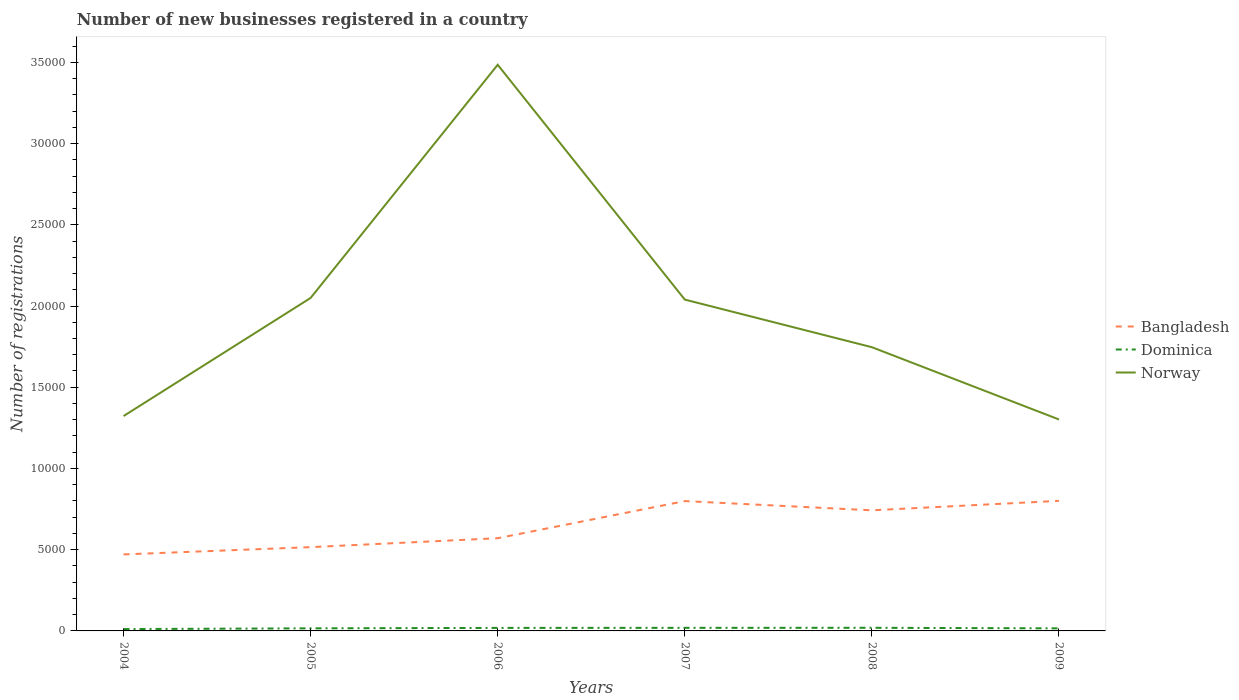How many different coloured lines are there?
Offer a terse response. 3. Across all years, what is the maximum number of new businesses registered in Dominica?
Offer a very short reply. 114. What is the total number of new businesses registered in Norway in the graph?
Keep it short and to the point. 7379. What is the difference between the highest and the second highest number of new businesses registered in Dominica?
Keep it short and to the point. 79. How many years are there in the graph?
Provide a succinct answer. 6. What is the difference between two consecutive major ticks on the Y-axis?
Provide a short and direct response. 5000. Are the values on the major ticks of Y-axis written in scientific E-notation?
Your answer should be compact. No. Does the graph contain any zero values?
Provide a succinct answer. No. Does the graph contain grids?
Keep it short and to the point. No. How many legend labels are there?
Offer a terse response. 3. How are the legend labels stacked?
Give a very brief answer. Vertical. What is the title of the graph?
Provide a short and direct response. Number of new businesses registered in a country. Does "Uganda" appear as one of the legend labels in the graph?
Provide a short and direct response. No. What is the label or title of the Y-axis?
Offer a very short reply. Number of registrations. What is the Number of registrations in Bangladesh in 2004?
Your answer should be compact. 4710. What is the Number of registrations of Dominica in 2004?
Your answer should be very brief. 114. What is the Number of registrations of Norway in 2004?
Your answer should be very brief. 1.32e+04. What is the Number of registrations of Bangladesh in 2005?
Make the answer very short. 5157. What is the Number of registrations in Dominica in 2005?
Offer a very short reply. 159. What is the Number of registrations of Norway in 2005?
Give a very brief answer. 2.05e+04. What is the Number of registrations in Bangladesh in 2006?
Your answer should be very brief. 5707. What is the Number of registrations in Dominica in 2006?
Offer a terse response. 186. What is the Number of registrations in Norway in 2006?
Give a very brief answer. 3.48e+04. What is the Number of registrations in Bangladesh in 2007?
Offer a terse response. 7992. What is the Number of registrations in Dominica in 2007?
Provide a short and direct response. 190. What is the Number of registrations in Norway in 2007?
Offer a very short reply. 2.04e+04. What is the Number of registrations of Bangladesh in 2008?
Your answer should be very brief. 7425. What is the Number of registrations of Dominica in 2008?
Provide a succinct answer. 193. What is the Number of registrations of Norway in 2008?
Ensure brevity in your answer.  1.75e+04. What is the Number of registrations of Bangladesh in 2009?
Offer a very short reply. 8007. What is the Number of registrations in Dominica in 2009?
Keep it short and to the point. 158. What is the Number of registrations in Norway in 2009?
Offer a very short reply. 1.30e+04. Across all years, what is the maximum Number of registrations in Bangladesh?
Your response must be concise. 8007. Across all years, what is the maximum Number of registrations in Dominica?
Provide a short and direct response. 193. Across all years, what is the maximum Number of registrations of Norway?
Provide a succinct answer. 3.48e+04. Across all years, what is the minimum Number of registrations of Bangladesh?
Keep it short and to the point. 4710. Across all years, what is the minimum Number of registrations of Dominica?
Provide a succinct answer. 114. Across all years, what is the minimum Number of registrations of Norway?
Provide a succinct answer. 1.30e+04. What is the total Number of registrations in Bangladesh in the graph?
Your answer should be very brief. 3.90e+04. What is the total Number of registrations in Norway in the graph?
Ensure brevity in your answer.  1.19e+05. What is the difference between the Number of registrations in Bangladesh in 2004 and that in 2005?
Your response must be concise. -447. What is the difference between the Number of registrations in Dominica in 2004 and that in 2005?
Make the answer very short. -45. What is the difference between the Number of registrations in Norway in 2004 and that in 2005?
Make the answer very short. -7272. What is the difference between the Number of registrations of Bangladesh in 2004 and that in 2006?
Provide a short and direct response. -997. What is the difference between the Number of registrations of Dominica in 2004 and that in 2006?
Provide a succinct answer. -72. What is the difference between the Number of registrations in Norway in 2004 and that in 2006?
Your answer should be very brief. -2.16e+04. What is the difference between the Number of registrations in Bangladesh in 2004 and that in 2007?
Give a very brief answer. -3282. What is the difference between the Number of registrations in Dominica in 2004 and that in 2007?
Offer a very short reply. -76. What is the difference between the Number of registrations of Norway in 2004 and that in 2007?
Ensure brevity in your answer.  -7170. What is the difference between the Number of registrations in Bangladesh in 2004 and that in 2008?
Your answer should be very brief. -2715. What is the difference between the Number of registrations in Dominica in 2004 and that in 2008?
Give a very brief answer. -79. What is the difference between the Number of registrations in Norway in 2004 and that in 2008?
Make the answer very short. -4240. What is the difference between the Number of registrations of Bangladesh in 2004 and that in 2009?
Give a very brief answer. -3297. What is the difference between the Number of registrations in Dominica in 2004 and that in 2009?
Provide a short and direct response. -44. What is the difference between the Number of registrations in Norway in 2004 and that in 2009?
Keep it short and to the point. 209. What is the difference between the Number of registrations in Bangladesh in 2005 and that in 2006?
Offer a very short reply. -550. What is the difference between the Number of registrations in Dominica in 2005 and that in 2006?
Give a very brief answer. -27. What is the difference between the Number of registrations of Norway in 2005 and that in 2006?
Keep it short and to the point. -1.44e+04. What is the difference between the Number of registrations in Bangladesh in 2005 and that in 2007?
Keep it short and to the point. -2835. What is the difference between the Number of registrations in Dominica in 2005 and that in 2007?
Give a very brief answer. -31. What is the difference between the Number of registrations of Norway in 2005 and that in 2007?
Provide a short and direct response. 102. What is the difference between the Number of registrations in Bangladesh in 2005 and that in 2008?
Your answer should be compact. -2268. What is the difference between the Number of registrations of Dominica in 2005 and that in 2008?
Your answer should be very brief. -34. What is the difference between the Number of registrations in Norway in 2005 and that in 2008?
Your answer should be compact. 3032. What is the difference between the Number of registrations in Bangladesh in 2005 and that in 2009?
Give a very brief answer. -2850. What is the difference between the Number of registrations of Dominica in 2005 and that in 2009?
Offer a terse response. 1. What is the difference between the Number of registrations in Norway in 2005 and that in 2009?
Give a very brief answer. 7481. What is the difference between the Number of registrations in Bangladesh in 2006 and that in 2007?
Your response must be concise. -2285. What is the difference between the Number of registrations of Dominica in 2006 and that in 2007?
Your answer should be very brief. -4. What is the difference between the Number of registrations in Norway in 2006 and that in 2007?
Offer a terse response. 1.45e+04. What is the difference between the Number of registrations of Bangladesh in 2006 and that in 2008?
Provide a short and direct response. -1718. What is the difference between the Number of registrations of Dominica in 2006 and that in 2008?
Your answer should be compact. -7. What is the difference between the Number of registrations of Norway in 2006 and that in 2008?
Make the answer very short. 1.74e+04. What is the difference between the Number of registrations of Bangladesh in 2006 and that in 2009?
Keep it short and to the point. -2300. What is the difference between the Number of registrations in Dominica in 2006 and that in 2009?
Offer a terse response. 28. What is the difference between the Number of registrations of Norway in 2006 and that in 2009?
Give a very brief answer. 2.18e+04. What is the difference between the Number of registrations of Bangladesh in 2007 and that in 2008?
Your response must be concise. 567. What is the difference between the Number of registrations of Dominica in 2007 and that in 2008?
Ensure brevity in your answer.  -3. What is the difference between the Number of registrations in Norway in 2007 and that in 2008?
Your answer should be compact. 2930. What is the difference between the Number of registrations in Bangladesh in 2007 and that in 2009?
Make the answer very short. -15. What is the difference between the Number of registrations of Dominica in 2007 and that in 2009?
Make the answer very short. 32. What is the difference between the Number of registrations of Norway in 2007 and that in 2009?
Keep it short and to the point. 7379. What is the difference between the Number of registrations of Bangladesh in 2008 and that in 2009?
Offer a terse response. -582. What is the difference between the Number of registrations in Dominica in 2008 and that in 2009?
Your response must be concise. 35. What is the difference between the Number of registrations of Norway in 2008 and that in 2009?
Provide a short and direct response. 4449. What is the difference between the Number of registrations in Bangladesh in 2004 and the Number of registrations in Dominica in 2005?
Make the answer very short. 4551. What is the difference between the Number of registrations in Bangladesh in 2004 and the Number of registrations in Norway in 2005?
Provide a short and direct response. -1.58e+04. What is the difference between the Number of registrations in Dominica in 2004 and the Number of registrations in Norway in 2005?
Offer a very short reply. -2.04e+04. What is the difference between the Number of registrations in Bangladesh in 2004 and the Number of registrations in Dominica in 2006?
Give a very brief answer. 4524. What is the difference between the Number of registrations in Bangladesh in 2004 and the Number of registrations in Norway in 2006?
Provide a short and direct response. -3.01e+04. What is the difference between the Number of registrations in Dominica in 2004 and the Number of registrations in Norway in 2006?
Your answer should be compact. -3.47e+04. What is the difference between the Number of registrations in Bangladesh in 2004 and the Number of registrations in Dominica in 2007?
Your answer should be compact. 4520. What is the difference between the Number of registrations in Bangladesh in 2004 and the Number of registrations in Norway in 2007?
Your response must be concise. -1.57e+04. What is the difference between the Number of registrations in Dominica in 2004 and the Number of registrations in Norway in 2007?
Provide a succinct answer. -2.03e+04. What is the difference between the Number of registrations of Bangladesh in 2004 and the Number of registrations of Dominica in 2008?
Keep it short and to the point. 4517. What is the difference between the Number of registrations in Bangladesh in 2004 and the Number of registrations in Norway in 2008?
Make the answer very short. -1.28e+04. What is the difference between the Number of registrations of Dominica in 2004 and the Number of registrations of Norway in 2008?
Your response must be concise. -1.74e+04. What is the difference between the Number of registrations in Bangladesh in 2004 and the Number of registrations in Dominica in 2009?
Ensure brevity in your answer.  4552. What is the difference between the Number of registrations in Bangladesh in 2004 and the Number of registrations in Norway in 2009?
Make the answer very short. -8306. What is the difference between the Number of registrations in Dominica in 2004 and the Number of registrations in Norway in 2009?
Offer a terse response. -1.29e+04. What is the difference between the Number of registrations in Bangladesh in 2005 and the Number of registrations in Dominica in 2006?
Your answer should be very brief. 4971. What is the difference between the Number of registrations in Bangladesh in 2005 and the Number of registrations in Norway in 2006?
Offer a terse response. -2.97e+04. What is the difference between the Number of registrations of Dominica in 2005 and the Number of registrations of Norway in 2006?
Provide a succinct answer. -3.47e+04. What is the difference between the Number of registrations of Bangladesh in 2005 and the Number of registrations of Dominica in 2007?
Offer a terse response. 4967. What is the difference between the Number of registrations of Bangladesh in 2005 and the Number of registrations of Norway in 2007?
Your response must be concise. -1.52e+04. What is the difference between the Number of registrations of Dominica in 2005 and the Number of registrations of Norway in 2007?
Your answer should be compact. -2.02e+04. What is the difference between the Number of registrations in Bangladesh in 2005 and the Number of registrations in Dominica in 2008?
Give a very brief answer. 4964. What is the difference between the Number of registrations in Bangladesh in 2005 and the Number of registrations in Norway in 2008?
Your answer should be very brief. -1.23e+04. What is the difference between the Number of registrations of Dominica in 2005 and the Number of registrations of Norway in 2008?
Ensure brevity in your answer.  -1.73e+04. What is the difference between the Number of registrations of Bangladesh in 2005 and the Number of registrations of Dominica in 2009?
Your answer should be compact. 4999. What is the difference between the Number of registrations of Bangladesh in 2005 and the Number of registrations of Norway in 2009?
Ensure brevity in your answer.  -7859. What is the difference between the Number of registrations in Dominica in 2005 and the Number of registrations in Norway in 2009?
Offer a terse response. -1.29e+04. What is the difference between the Number of registrations of Bangladesh in 2006 and the Number of registrations of Dominica in 2007?
Keep it short and to the point. 5517. What is the difference between the Number of registrations in Bangladesh in 2006 and the Number of registrations in Norway in 2007?
Your response must be concise. -1.47e+04. What is the difference between the Number of registrations in Dominica in 2006 and the Number of registrations in Norway in 2007?
Offer a very short reply. -2.02e+04. What is the difference between the Number of registrations in Bangladesh in 2006 and the Number of registrations in Dominica in 2008?
Offer a very short reply. 5514. What is the difference between the Number of registrations in Bangladesh in 2006 and the Number of registrations in Norway in 2008?
Make the answer very short. -1.18e+04. What is the difference between the Number of registrations in Dominica in 2006 and the Number of registrations in Norway in 2008?
Provide a succinct answer. -1.73e+04. What is the difference between the Number of registrations in Bangladesh in 2006 and the Number of registrations in Dominica in 2009?
Your answer should be compact. 5549. What is the difference between the Number of registrations of Bangladesh in 2006 and the Number of registrations of Norway in 2009?
Provide a succinct answer. -7309. What is the difference between the Number of registrations of Dominica in 2006 and the Number of registrations of Norway in 2009?
Keep it short and to the point. -1.28e+04. What is the difference between the Number of registrations in Bangladesh in 2007 and the Number of registrations in Dominica in 2008?
Provide a succinct answer. 7799. What is the difference between the Number of registrations of Bangladesh in 2007 and the Number of registrations of Norway in 2008?
Provide a short and direct response. -9473. What is the difference between the Number of registrations in Dominica in 2007 and the Number of registrations in Norway in 2008?
Give a very brief answer. -1.73e+04. What is the difference between the Number of registrations of Bangladesh in 2007 and the Number of registrations of Dominica in 2009?
Offer a very short reply. 7834. What is the difference between the Number of registrations of Bangladesh in 2007 and the Number of registrations of Norway in 2009?
Ensure brevity in your answer.  -5024. What is the difference between the Number of registrations in Dominica in 2007 and the Number of registrations in Norway in 2009?
Offer a terse response. -1.28e+04. What is the difference between the Number of registrations in Bangladesh in 2008 and the Number of registrations in Dominica in 2009?
Your answer should be very brief. 7267. What is the difference between the Number of registrations of Bangladesh in 2008 and the Number of registrations of Norway in 2009?
Give a very brief answer. -5591. What is the difference between the Number of registrations of Dominica in 2008 and the Number of registrations of Norway in 2009?
Offer a very short reply. -1.28e+04. What is the average Number of registrations in Bangladesh per year?
Your answer should be compact. 6499.67. What is the average Number of registrations of Dominica per year?
Offer a very short reply. 166.67. What is the average Number of registrations of Norway per year?
Your response must be concise. 1.99e+04. In the year 2004, what is the difference between the Number of registrations in Bangladesh and Number of registrations in Dominica?
Your response must be concise. 4596. In the year 2004, what is the difference between the Number of registrations of Bangladesh and Number of registrations of Norway?
Provide a short and direct response. -8515. In the year 2004, what is the difference between the Number of registrations of Dominica and Number of registrations of Norway?
Give a very brief answer. -1.31e+04. In the year 2005, what is the difference between the Number of registrations of Bangladesh and Number of registrations of Dominica?
Keep it short and to the point. 4998. In the year 2005, what is the difference between the Number of registrations in Bangladesh and Number of registrations in Norway?
Provide a succinct answer. -1.53e+04. In the year 2005, what is the difference between the Number of registrations in Dominica and Number of registrations in Norway?
Your answer should be very brief. -2.03e+04. In the year 2006, what is the difference between the Number of registrations in Bangladesh and Number of registrations in Dominica?
Your answer should be very brief. 5521. In the year 2006, what is the difference between the Number of registrations in Bangladesh and Number of registrations in Norway?
Offer a very short reply. -2.91e+04. In the year 2006, what is the difference between the Number of registrations in Dominica and Number of registrations in Norway?
Offer a terse response. -3.47e+04. In the year 2007, what is the difference between the Number of registrations in Bangladesh and Number of registrations in Dominica?
Your answer should be compact. 7802. In the year 2007, what is the difference between the Number of registrations in Bangladesh and Number of registrations in Norway?
Give a very brief answer. -1.24e+04. In the year 2007, what is the difference between the Number of registrations of Dominica and Number of registrations of Norway?
Ensure brevity in your answer.  -2.02e+04. In the year 2008, what is the difference between the Number of registrations in Bangladesh and Number of registrations in Dominica?
Offer a very short reply. 7232. In the year 2008, what is the difference between the Number of registrations in Bangladesh and Number of registrations in Norway?
Provide a short and direct response. -1.00e+04. In the year 2008, what is the difference between the Number of registrations of Dominica and Number of registrations of Norway?
Make the answer very short. -1.73e+04. In the year 2009, what is the difference between the Number of registrations of Bangladesh and Number of registrations of Dominica?
Provide a succinct answer. 7849. In the year 2009, what is the difference between the Number of registrations of Bangladesh and Number of registrations of Norway?
Offer a very short reply. -5009. In the year 2009, what is the difference between the Number of registrations of Dominica and Number of registrations of Norway?
Your response must be concise. -1.29e+04. What is the ratio of the Number of registrations of Bangladesh in 2004 to that in 2005?
Make the answer very short. 0.91. What is the ratio of the Number of registrations in Dominica in 2004 to that in 2005?
Ensure brevity in your answer.  0.72. What is the ratio of the Number of registrations of Norway in 2004 to that in 2005?
Provide a short and direct response. 0.65. What is the ratio of the Number of registrations of Bangladesh in 2004 to that in 2006?
Provide a short and direct response. 0.83. What is the ratio of the Number of registrations in Dominica in 2004 to that in 2006?
Provide a succinct answer. 0.61. What is the ratio of the Number of registrations of Norway in 2004 to that in 2006?
Offer a terse response. 0.38. What is the ratio of the Number of registrations in Bangladesh in 2004 to that in 2007?
Offer a terse response. 0.59. What is the ratio of the Number of registrations of Dominica in 2004 to that in 2007?
Keep it short and to the point. 0.6. What is the ratio of the Number of registrations in Norway in 2004 to that in 2007?
Ensure brevity in your answer.  0.65. What is the ratio of the Number of registrations of Bangladesh in 2004 to that in 2008?
Give a very brief answer. 0.63. What is the ratio of the Number of registrations in Dominica in 2004 to that in 2008?
Make the answer very short. 0.59. What is the ratio of the Number of registrations in Norway in 2004 to that in 2008?
Keep it short and to the point. 0.76. What is the ratio of the Number of registrations in Bangladesh in 2004 to that in 2009?
Your answer should be compact. 0.59. What is the ratio of the Number of registrations of Dominica in 2004 to that in 2009?
Ensure brevity in your answer.  0.72. What is the ratio of the Number of registrations in Norway in 2004 to that in 2009?
Ensure brevity in your answer.  1.02. What is the ratio of the Number of registrations of Bangladesh in 2005 to that in 2006?
Make the answer very short. 0.9. What is the ratio of the Number of registrations in Dominica in 2005 to that in 2006?
Ensure brevity in your answer.  0.85. What is the ratio of the Number of registrations of Norway in 2005 to that in 2006?
Offer a terse response. 0.59. What is the ratio of the Number of registrations in Bangladesh in 2005 to that in 2007?
Offer a terse response. 0.65. What is the ratio of the Number of registrations of Dominica in 2005 to that in 2007?
Offer a terse response. 0.84. What is the ratio of the Number of registrations of Bangladesh in 2005 to that in 2008?
Provide a succinct answer. 0.69. What is the ratio of the Number of registrations of Dominica in 2005 to that in 2008?
Make the answer very short. 0.82. What is the ratio of the Number of registrations in Norway in 2005 to that in 2008?
Provide a short and direct response. 1.17. What is the ratio of the Number of registrations in Bangladesh in 2005 to that in 2009?
Make the answer very short. 0.64. What is the ratio of the Number of registrations in Dominica in 2005 to that in 2009?
Keep it short and to the point. 1.01. What is the ratio of the Number of registrations in Norway in 2005 to that in 2009?
Offer a very short reply. 1.57. What is the ratio of the Number of registrations of Bangladesh in 2006 to that in 2007?
Give a very brief answer. 0.71. What is the ratio of the Number of registrations in Dominica in 2006 to that in 2007?
Give a very brief answer. 0.98. What is the ratio of the Number of registrations of Norway in 2006 to that in 2007?
Make the answer very short. 1.71. What is the ratio of the Number of registrations in Bangladesh in 2006 to that in 2008?
Make the answer very short. 0.77. What is the ratio of the Number of registrations in Dominica in 2006 to that in 2008?
Provide a succinct answer. 0.96. What is the ratio of the Number of registrations of Norway in 2006 to that in 2008?
Ensure brevity in your answer.  2. What is the ratio of the Number of registrations in Bangladesh in 2006 to that in 2009?
Keep it short and to the point. 0.71. What is the ratio of the Number of registrations in Dominica in 2006 to that in 2009?
Offer a very short reply. 1.18. What is the ratio of the Number of registrations in Norway in 2006 to that in 2009?
Offer a very short reply. 2.68. What is the ratio of the Number of registrations of Bangladesh in 2007 to that in 2008?
Provide a succinct answer. 1.08. What is the ratio of the Number of registrations in Dominica in 2007 to that in 2008?
Offer a very short reply. 0.98. What is the ratio of the Number of registrations of Norway in 2007 to that in 2008?
Provide a succinct answer. 1.17. What is the ratio of the Number of registrations in Dominica in 2007 to that in 2009?
Provide a short and direct response. 1.2. What is the ratio of the Number of registrations in Norway in 2007 to that in 2009?
Give a very brief answer. 1.57. What is the ratio of the Number of registrations in Bangladesh in 2008 to that in 2009?
Provide a succinct answer. 0.93. What is the ratio of the Number of registrations of Dominica in 2008 to that in 2009?
Ensure brevity in your answer.  1.22. What is the ratio of the Number of registrations of Norway in 2008 to that in 2009?
Give a very brief answer. 1.34. What is the difference between the highest and the second highest Number of registrations of Bangladesh?
Ensure brevity in your answer.  15. What is the difference between the highest and the second highest Number of registrations of Norway?
Your response must be concise. 1.44e+04. What is the difference between the highest and the lowest Number of registrations in Bangladesh?
Keep it short and to the point. 3297. What is the difference between the highest and the lowest Number of registrations of Dominica?
Ensure brevity in your answer.  79. What is the difference between the highest and the lowest Number of registrations in Norway?
Provide a short and direct response. 2.18e+04. 